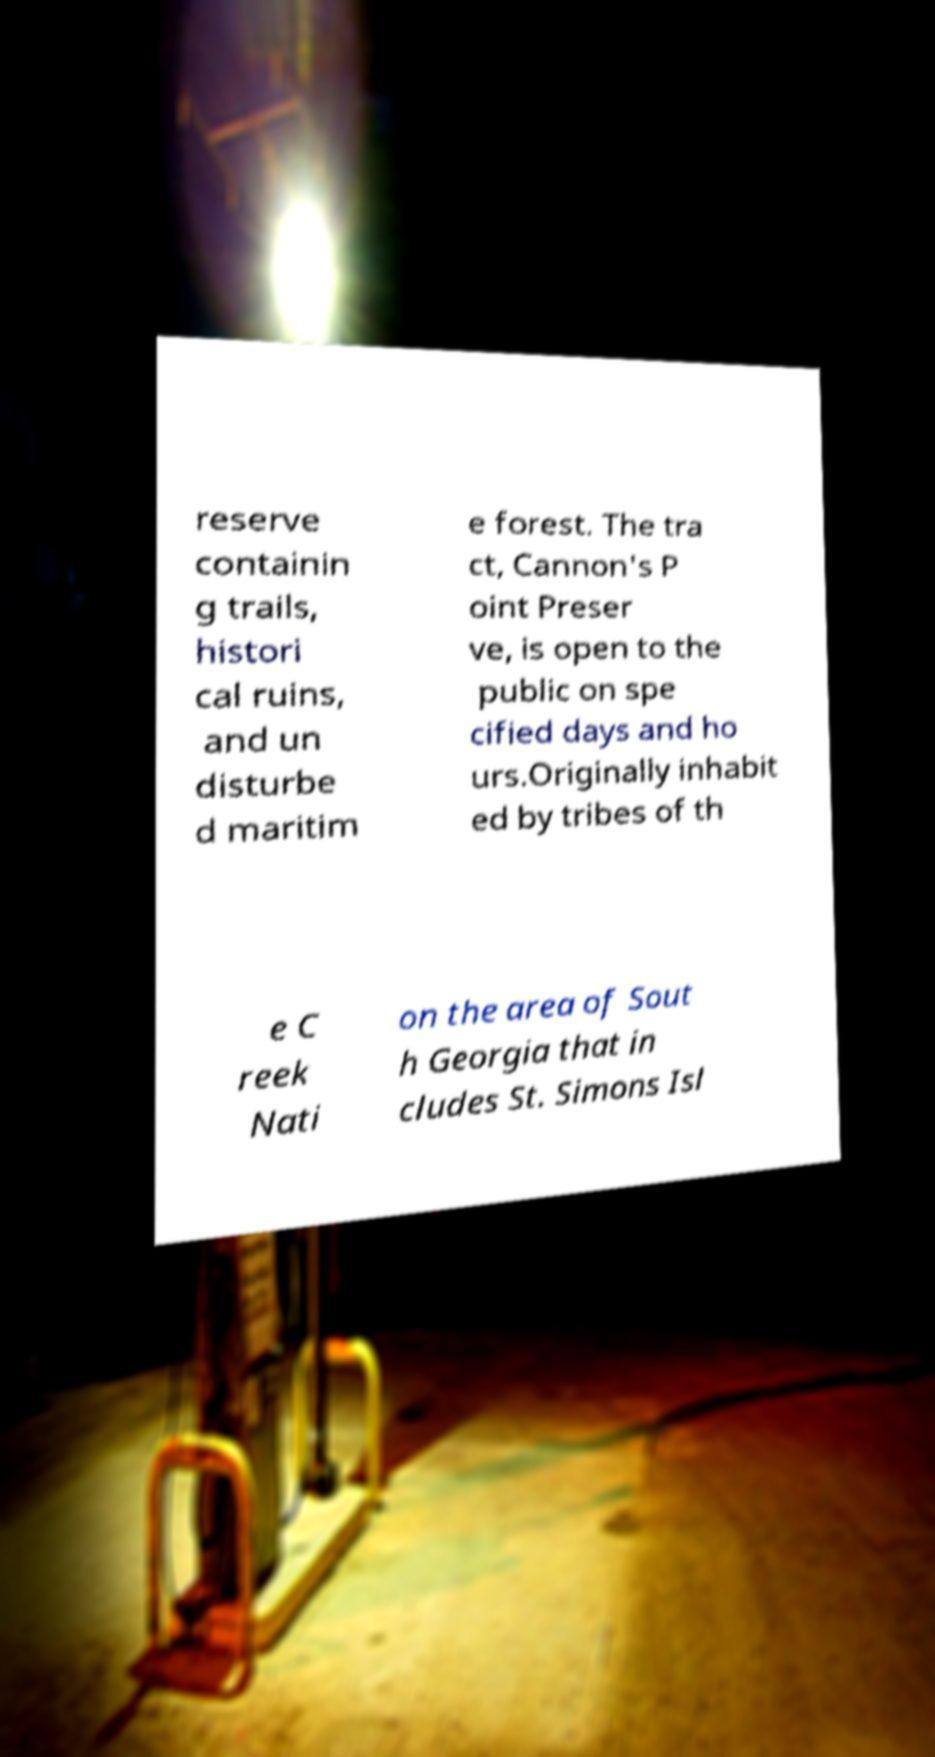Could you assist in decoding the text presented in this image and type it out clearly? reserve containin g trails, histori cal ruins, and un disturbe d maritim e forest. The tra ct, Cannon's P oint Preser ve, is open to the public on spe cified days and ho urs.Originally inhabit ed by tribes of th e C reek Nati on the area of Sout h Georgia that in cludes St. Simons Isl 